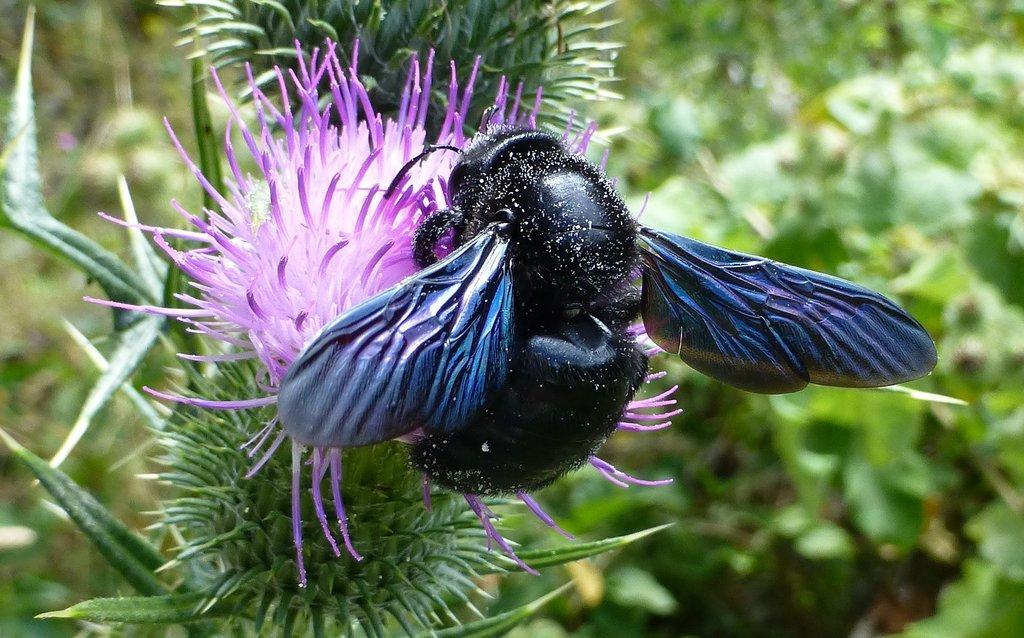How would you summarize this image in a sentence or two? In this picture, we see an insect is on the flower. I think the insect is sucking honey from the flower. In this picture, we see a plant which has flower. This flower is in violet color. In the background, there are trees or plants. It is blurred in the background. 